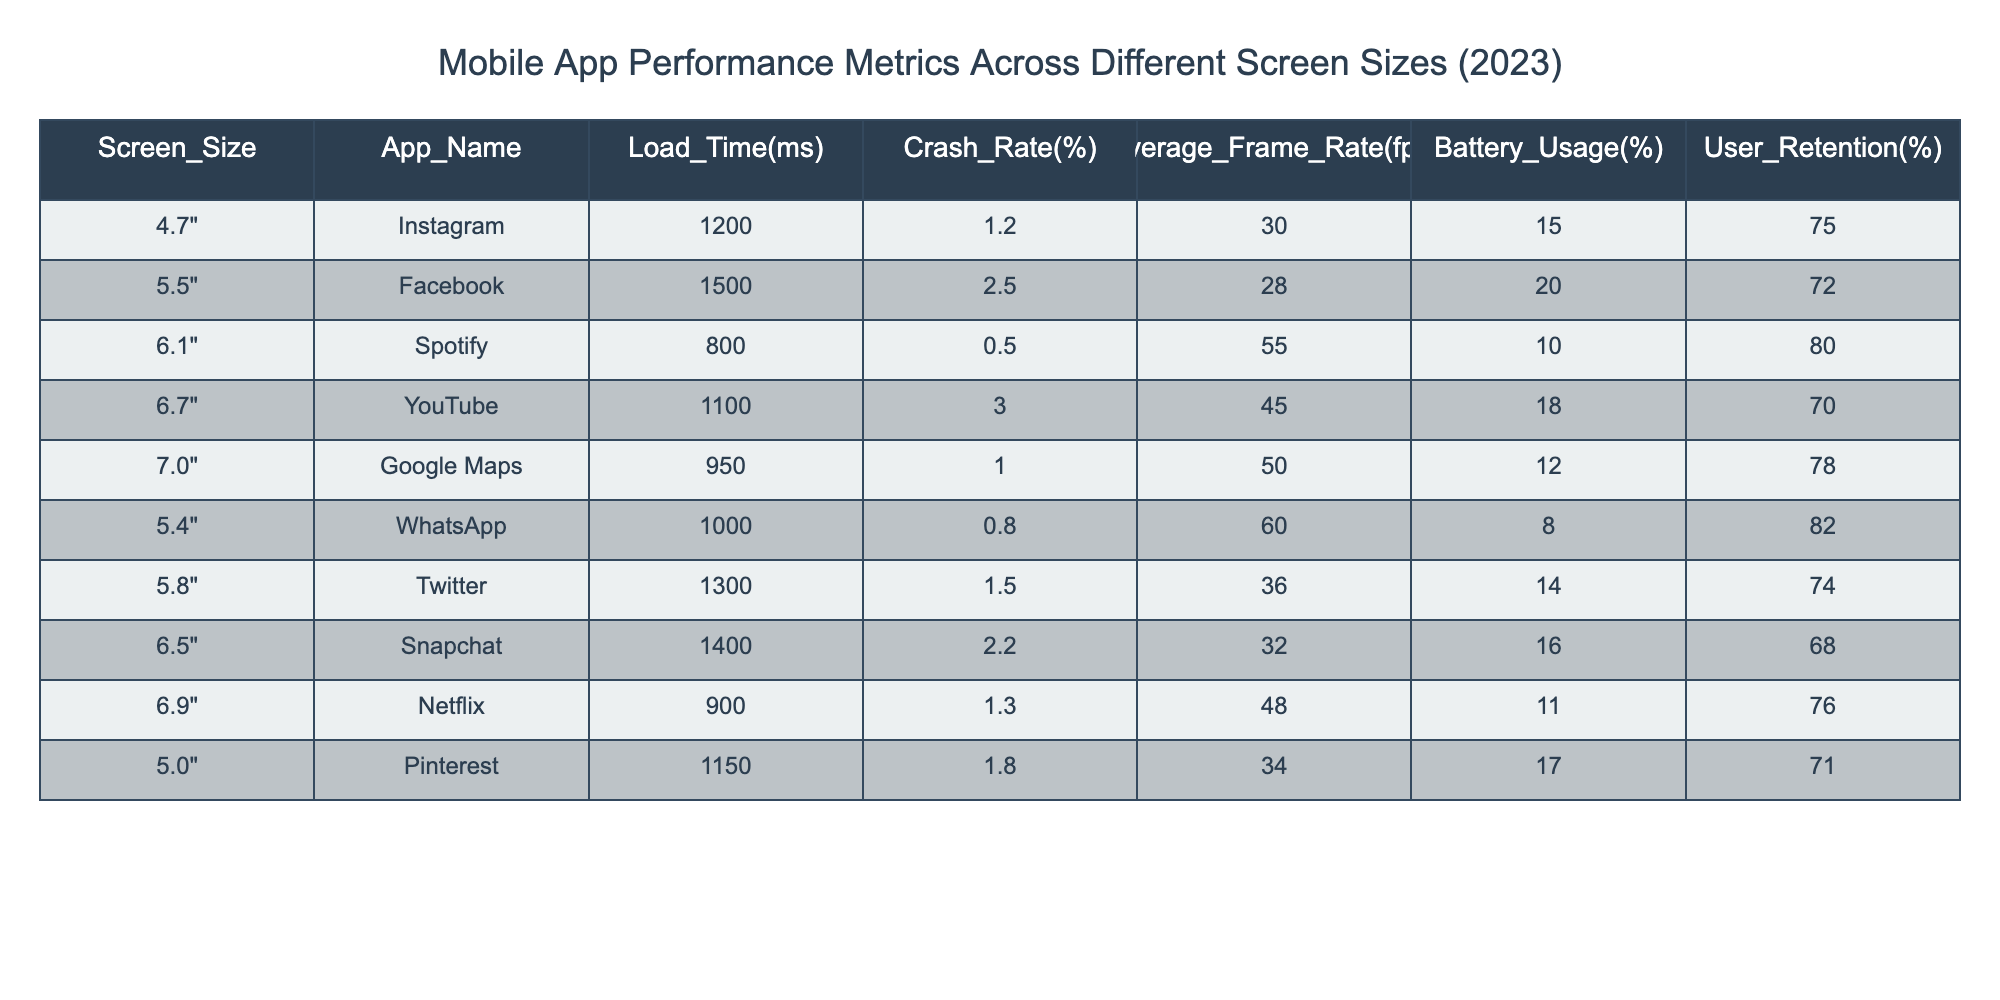What is the load time for the YouTube app? The load time for the YouTube app is listed in the table under the "Load_Time(ms)" column corresponding to "YouTube". It shows the value as 1100 milliseconds.
Answer: 1100 ms Which app has the highest crash rate? To determine the highest crash rate, I look for the maximum value in the "Crash_Rate(%)" column. The Facebook app has a crash rate of 2.5%, which is the highest among all apps listed.
Answer: Facebook What is the average battery usage for apps that have a screen size of 5.5 inches or less? We first identify the apps with screen sizes of 5.5 inches or less, which are Instagram (15%), Facebook (20%), and WhatsApp (8%). Adding these values gives 15 + 20 + 8 = 43%. There are three apps, so the average battery usage is 43% / 3 = 14.33%.
Answer: 14.33% Is there an app with a user retention rate above 80%? The question checks the "User_Retention(%)" column for values greater than 80%. Both Spotify (80%) and WhatsApp (82%) have retention rates above 80%, confirming that at least one app meets the criterion.
Answer: Yes What is the difference in average frame rate between the highest and lowest performing apps in that category? The highest average frame rate is from WhatsApp at 60 fps, and the lowest is from Facebook at 28 fps. The difference is calculated as 60 - 28 = 32 fps.
Answer: 32 fps What is the average load time of apps that have a screen size of 6.1 inches or more? We identify the apps with screen sizes of 6.1 inches or more, which are Spotify (800 ms), YouTube (1100 ms), Google Maps (950 ms), Snapchat (1400 ms), Netflix (900 ms), and Pinterest (1150 ms). The total load time is 800 + 1100 + 950 + 1400 + 900 + 1150 = 6300 ms. With 6 apps, the average load time is 6300 ms / 6 = 1050 ms.
Answer: 1050 ms 